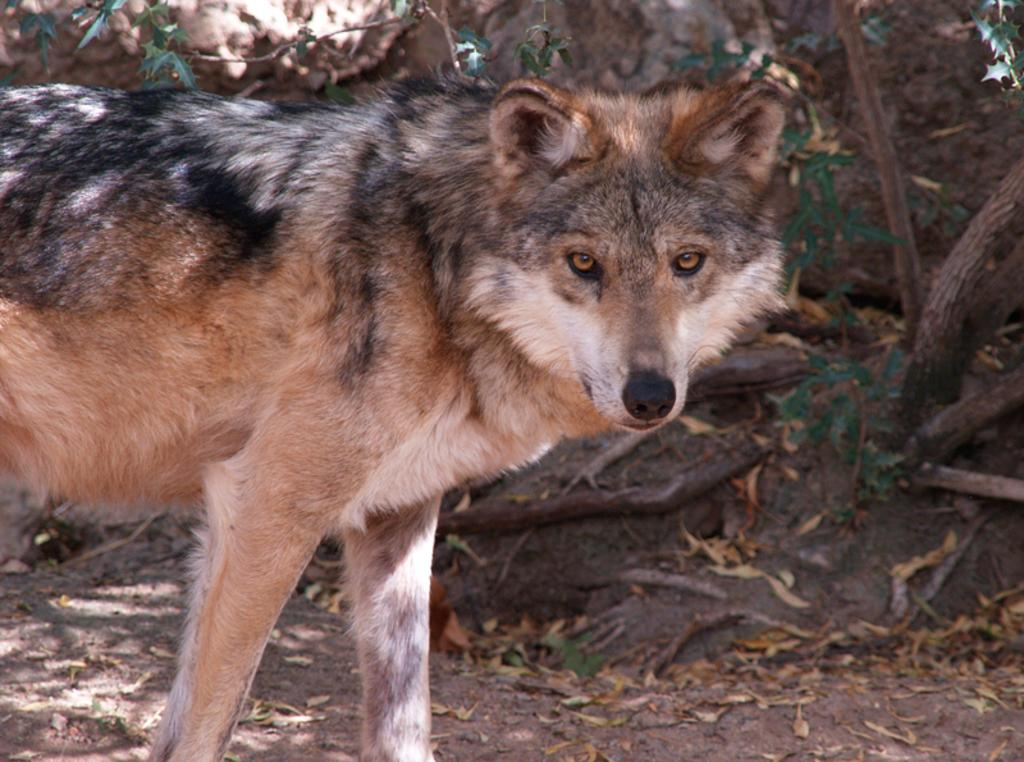What type of animal is in the image? The animal in the image is not specified, but it has black, cream, and brown colors. What is the animal's position in the image? The animal is standing on the ground in the image. What can be seen in the background of the image? There are trees and leaves on the ground in the background of the image. What type of thread is being used to join the scissors in the image? There are no scissors or thread present in the image. 